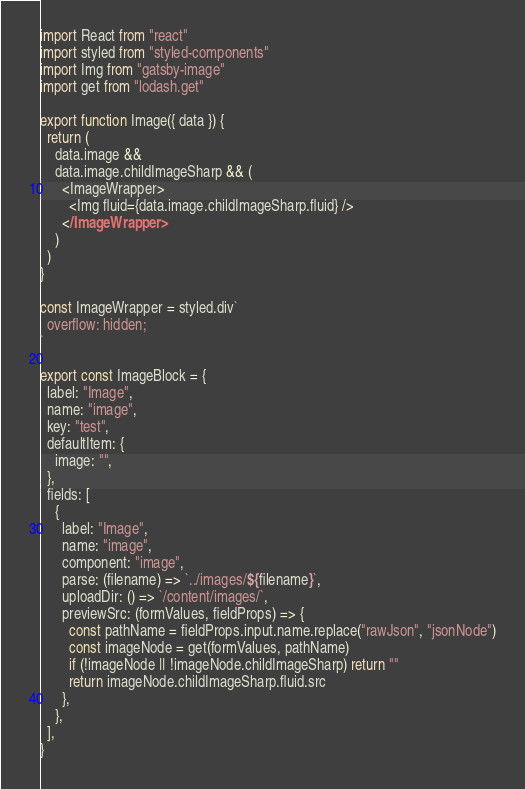<code> <loc_0><loc_0><loc_500><loc_500><_JavaScript_>import React from "react"
import styled from "styled-components"
import Img from "gatsby-image"
import get from "lodash.get"

export function Image({ data }) {
  return (
    data.image &&
    data.image.childImageSharp && (
      <ImageWrapper>
        <Img fluid={data.image.childImageSharp.fluid} />
      </ImageWrapper>
    )
  )
}

const ImageWrapper = styled.div`
  overflow: hidden;
`

export const ImageBlock = {
  label: "Image",
  name: "image",
  key: "test",
  defaultItem: {
    image: "",
  },
  fields: [
    {
      label: "Image",
      name: "image",
      component: "image",
      parse: (filename) => `../images/${filename}`,
      uploadDir: () => `/content/images/`,
      previewSrc: (formValues, fieldProps) => {
        const pathName = fieldProps.input.name.replace("rawJson", "jsonNode")
        const imageNode = get(formValues, pathName)
        if (!imageNode || !imageNode.childImageSharp) return ""
        return imageNode.childImageSharp.fluid.src
      },
    },
  ],
}
</code> 